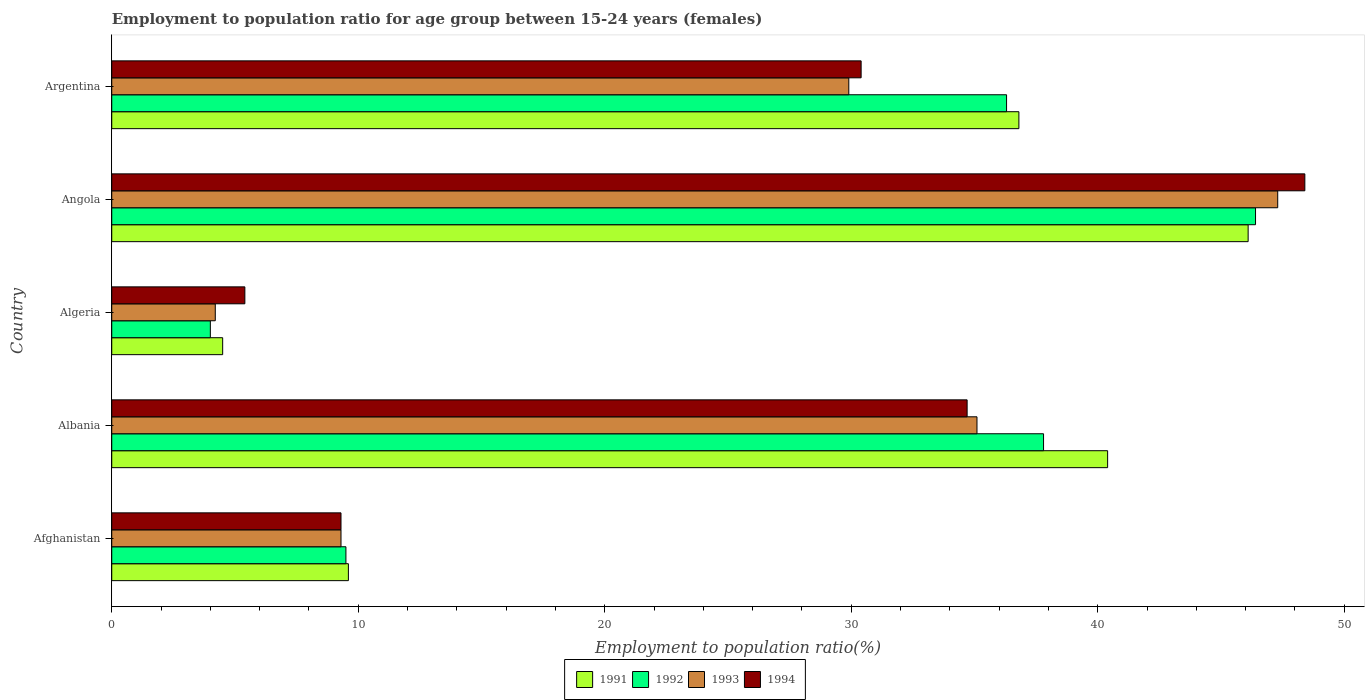How many different coloured bars are there?
Ensure brevity in your answer.  4. How many groups of bars are there?
Your answer should be compact. 5. What is the label of the 5th group of bars from the top?
Your response must be concise. Afghanistan. What is the employment to population ratio in 1993 in Angola?
Provide a short and direct response. 47.3. Across all countries, what is the maximum employment to population ratio in 1991?
Ensure brevity in your answer.  46.1. Across all countries, what is the minimum employment to population ratio in 1993?
Provide a succinct answer. 4.2. In which country was the employment to population ratio in 1994 maximum?
Your answer should be compact. Angola. In which country was the employment to population ratio in 1992 minimum?
Keep it short and to the point. Algeria. What is the total employment to population ratio in 1993 in the graph?
Keep it short and to the point. 125.8. What is the difference between the employment to population ratio in 1994 in Afghanistan and that in Argentina?
Keep it short and to the point. -21.1. What is the difference between the employment to population ratio in 1991 in Argentina and the employment to population ratio in 1992 in Algeria?
Ensure brevity in your answer.  32.8. What is the average employment to population ratio in 1991 per country?
Keep it short and to the point. 27.48. What is the difference between the employment to population ratio in 1992 and employment to population ratio in 1993 in Argentina?
Your response must be concise. 6.4. In how many countries, is the employment to population ratio in 1993 greater than 4 %?
Make the answer very short. 5. What is the ratio of the employment to population ratio in 1992 in Afghanistan to that in Albania?
Ensure brevity in your answer.  0.25. Is the employment to population ratio in 1992 in Afghanistan less than that in Argentina?
Provide a succinct answer. Yes. What is the difference between the highest and the second highest employment to population ratio in 1991?
Make the answer very short. 5.7. What is the difference between the highest and the lowest employment to population ratio in 1994?
Keep it short and to the point. 43. Is it the case that in every country, the sum of the employment to population ratio in 1993 and employment to population ratio in 1991 is greater than the sum of employment to population ratio in 1994 and employment to population ratio in 1992?
Offer a very short reply. No. Is it the case that in every country, the sum of the employment to population ratio in 1991 and employment to population ratio in 1993 is greater than the employment to population ratio in 1994?
Offer a terse response. Yes. Are the values on the major ticks of X-axis written in scientific E-notation?
Ensure brevity in your answer.  No. Does the graph contain any zero values?
Keep it short and to the point. No. How many legend labels are there?
Give a very brief answer. 4. What is the title of the graph?
Provide a succinct answer. Employment to population ratio for age group between 15-24 years (females). Does "1971" appear as one of the legend labels in the graph?
Ensure brevity in your answer.  No. What is the label or title of the X-axis?
Your answer should be compact. Employment to population ratio(%). What is the label or title of the Y-axis?
Offer a very short reply. Country. What is the Employment to population ratio(%) of 1991 in Afghanistan?
Provide a succinct answer. 9.6. What is the Employment to population ratio(%) in 1992 in Afghanistan?
Give a very brief answer. 9.5. What is the Employment to population ratio(%) of 1993 in Afghanistan?
Provide a succinct answer. 9.3. What is the Employment to population ratio(%) of 1994 in Afghanistan?
Your answer should be very brief. 9.3. What is the Employment to population ratio(%) in 1991 in Albania?
Offer a terse response. 40.4. What is the Employment to population ratio(%) of 1992 in Albania?
Your answer should be very brief. 37.8. What is the Employment to population ratio(%) in 1993 in Albania?
Ensure brevity in your answer.  35.1. What is the Employment to population ratio(%) of 1994 in Albania?
Offer a very short reply. 34.7. What is the Employment to population ratio(%) of 1992 in Algeria?
Offer a very short reply. 4. What is the Employment to population ratio(%) in 1993 in Algeria?
Give a very brief answer. 4.2. What is the Employment to population ratio(%) in 1994 in Algeria?
Your answer should be compact. 5.4. What is the Employment to population ratio(%) in 1991 in Angola?
Offer a terse response. 46.1. What is the Employment to population ratio(%) of 1992 in Angola?
Offer a terse response. 46.4. What is the Employment to population ratio(%) in 1993 in Angola?
Give a very brief answer. 47.3. What is the Employment to population ratio(%) of 1994 in Angola?
Provide a short and direct response. 48.4. What is the Employment to population ratio(%) of 1991 in Argentina?
Provide a succinct answer. 36.8. What is the Employment to population ratio(%) in 1992 in Argentina?
Make the answer very short. 36.3. What is the Employment to population ratio(%) in 1993 in Argentina?
Your answer should be compact. 29.9. What is the Employment to population ratio(%) of 1994 in Argentina?
Provide a succinct answer. 30.4. Across all countries, what is the maximum Employment to population ratio(%) in 1991?
Your response must be concise. 46.1. Across all countries, what is the maximum Employment to population ratio(%) of 1992?
Give a very brief answer. 46.4. Across all countries, what is the maximum Employment to population ratio(%) of 1993?
Ensure brevity in your answer.  47.3. Across all countries, what is the maximum Employment to population ratio(%) of 1994?
Offer a terse response. 48.4. Across all countries, what is the minimum Employment to population ratio(%) in 1991?
Your answer should be very brief. 4.5. Across all countries, what is the minimum Employment to population ratio(%) in 1993?
Ensure brevity in your answer.  4.2. Across all countries, what is the minimum Employment to population ratio(%) in 1994?
Your answer should be compact. 5.4. What is the total Employment to population ratio(%) of 1991 in the graph?
Make the answer very short. 137.4. What is the total Employment to population ratio(%) of 1992 in the graph?
Give a very brief answer. 134. What is the total Employment to population ratio(%) of 1993 in the graph?
Your response must be concise. 125.8. What is the total Employment to population ratio(%) in 1994 in the graph?
Your answer should be very brief. 128.2. What is the difference between the Employment to population ratio(%) of 1991 in Afghanistan and that in Albania?
Your response must be concise. -30.8. What is the difference between the Employment to population ratio(%) of 1992 in Afghanistan and that in Albania?
Provide a short and direct response. -28.3. What is the difference between the Employment to population ratio(%) in 1993 in Afghanistan and that in Albania?
Provide a short and direct response. -25.8. What is the difference between the Employment to population ratio(%) in 1994 in Afghanistan and that in Albania?
Your answer should be compact. -25.4. What is the difference between the Employment to population ratio(%) in 1991 in Afghanistan and that in Algeria?
Ensure brevity in your answer.  5.1. What is the difference between the Employment to population ratio(%) of 1993 in Afghanistan and that in Algeria?
Keep it short and to the point. 5.1. What is the difference between the Employment to population ratio(%) of 1994 in Afghanistan and that in Algeria?
Keep it short and to the point. 3.9. What is the difference between the Employment to population ratio(%) of 1991 in Afghanistan and that in Angola?
Keep it short and to the point. -36.5. What is the difference between the Employment to population ratio(%) of 1992 in Afghanistan and that in Angola?
Provide a short and direct response. -36.9. What is the difference between the Employment to population ratio(%) of 1993 in Afghanistan and that in Angola?
Provide a short and direct response. -38. What is the difference between the Employment to population ratio(%) in 1994 in Afghanistan and that in Angola?
Make the answer very short. -39.1. What is the difference between the Employment to population ratio(%) in 1991 in Afghanistan and that in Argentina?
Make the answer very short. -27.2. What is the difference between the Employment to population ratio(%) of 1992 in Afghanistan and that in Argentina?
Your answer should be very brief. -26.8. What is the difference between the Employment to population ratio(%) of 1993 in Afghanistan and that in Argentina?
Give a very brief answer. -20.6. What is the difference between the Employment to population ratio(%) in 1994 in Afghanistan and that in Argentina?
Offer a very short reply. -21.1. What is the difference between the Employment to population ratio(%) of 1991 in Albania and that in Algeria?
Your response must be concise. 35.9. What is the difference between the Employment to population ratio(%) of 1992 in Albania and that in Algeria?
Give a very brief answer. 33.8. What is the difference between the Employment to population ratio(%) of 1993 in Albania and that in Algeria?
Your answer should be very brief. 30.9. What is the difference between the Employment to population ratio(%) in 1994 in Albania and that in Algeria?
Ensure brevity in your answer.  29.3. What is the difference between the Employment to population ratio(%) in 1993 in Albania and that in Angola?
Provide a short and direct response. -12.2. What is the difference between the Employment to population ratio(%) of 1994 in Albania and that in Angola?
Offer a terse response. -13.7. What is the difference between the Employment to population ratio(%) of 1991 in Albania and that in Argentina?
Provide a succinct answer. 3.6. What is the difference between the Employment to population ratio(%) of 1992 in Albania and that in Argentina?
Offer a very short reply. 1.5. What is the difference between the Employment to population ratio(%) in 1991 in Algeria and that in Angola?
Make the answer very short. -41.6. What is the difference between the Employment to population ratio(%) in 1992 in Algeria and that in Angola?
Your response must be concise. -42.4. What is the difference between the Employment to population ratio(%) of 1993 in Algeria and that in Angola?
Your answer should be compact. -43.1. What is the difference between the Employment to population ratio(%) in 1994 in Algeria and that in Angola?
Your answer should be very brief. -43. What is the difference between the Employment to population ratio(%) in 1991 in Algeria and that in Argentina?
Offer a terse response. -32.3. What is the difference between the Employment to population ratio(%) of 1992 in Algeria and that in Argentina?
Your response must be concise. -32.3. What is the difference between the Employment to population ratio(%) in 1993 in Algeria and that in Argentina?
Ensure brevity in your answer.  -25.7. What is the difference between the Employment to population ratio(%) in 1994 in Algeria and that in Argentina?
Keep it short and to the point. -25. What is the difference between the Employment to population ratio(%) of 1992 in Angola and that in Argentina?
Offer a terse response. 10.1. What is the difference between the Employment to population ratio(%) of 1994 in Angola and that in Argentina?
Your answer should be compact. 18. What is the difference between the Employment to population ratio(%) in 1991 in Afghanistan and the Employment to population ratio(%) in 1992 in Albania?
Offer a very short reply. -28.2. What is the difference between the Employment to population ratio(%) of 1991 in Afghanistan and the Employment to population ratio(%) of 1993 in Albania?
Ensure brevity in your answer.  -25.5. What is the difference between the Employment to population ratio(%) in 1991 in Afghanistan and the Employment to population ratio(%) in 1994 in Albania?
Make the answer very short. -25.1. What is the difference between the Employment to population ratio(%) in 1992 in Afghanistan and the Employment to population ratio(%) in 1993 in Albania?
Keep it short and to the point. -25.6. What is the difference between the Employment to population ratio(%) of 1992 in Afghanistan and the Employment to population ratio(%) of 1994 in Albania?
Your response must be concise. -25.2. What is the difference between the Employment to population ratio(%) of 1993 in Afghanistan and the Employment to population ratio(%) of 1994 in Albania?
Keep it short and to the point. -25.4. What is the difference between the Employment to population ratio(%) in 1991 in Afghanistan and the Employment to population ratio(%) in 1992 in Algeria?
Your answer should be very brief. 5.6. What is the difference between the Employment to population ratio(%) of 1991 in Afghanistan and the Employment to population ratio(%) of 1993 in Algeria?
Keep it short and to the point. 5.4. What is the difference between the Employment to population ratio(%) in 1992 in Afghanistan and the Employment to population ratio(%) in 1993 in Algeria?
Keep it short and to the point. 5.3. What is the difference between the Employment to population ratio(%) in 1992 in Afghanistan and the Employment to population ratio(%) in 1994 in Algeria?
Provide a short and direct response. 4.1. What is the difference between the Employment to population ratio(%) of 1993 in Afghanistan and the Employment to population ratio(%) of 1994 in Algeria?
Keep it short and to the point. 3.9. What is the difference between the Employment to population ratio(%) of 1991 in Afghanistan and the Employment to population ratio(%) of 1992 in Angola?
Offer a very short reply. -36.8. What is the difference between the Employment to population ratio(%) in 1991 in Afghanistan and the Employment to population ratio(%) in 1993 in Angola?
Provide a short and direct response. -37.7. What is the difference between the Employment to population ratio(%) in 1991 in Afghanistan and the Employment to population ratio(%) in 1994 in Angola?
Offer a terse response. -38.8. What is the difference between the Employment to population ratio(%) of 1992 in Afghanistan and the Employment to population ratio(%) of 1993 in Angola?
Keep it short and to the point. -37.8. What is the difference between the Employment to population ratio(%) in 1992 in Afghanistan and the Employment to population ratio(%) in 1994 in Angola?
Ensure brevity in your answer.  -38.9. What is the difference between the Employment to population ratio(%) in 1993 in Afghanistan and the Employment to population ratio(%) in 1994 in Angola?
Provide a succinct answer. -39.1. What is the difference between the Employment to population ratio(%) of 1991 in Afghanistan and the Employment to population ratio(%) of 1992 in Argentina?
Keep it short and to the point. -26.7. What is the difference between the Employment to population ratio(%) of 1991 in Afghanistan and the Employment to population ratio(%) of 1993 in Argentina?
Ensure brevity in your answer.  -20.3. What is the difference between the Employment to population ratio(%) of 1991 in Afghanistan and the Employment to population ratio(%) of 1994 in Argentina?
Provide a succinct answer. -20.8. What is the difference between the Employment to population ratio(%) in 1992 in Afghanistan and the Employment to population ratio(%) in 1993 in Argentina?
Your answer should be very brief. -20.4. What is the difference between the Employment to population ratio(%) in 1992 in Afghanistan and the Employment to population ratio(%) in 1994 in Argentina?
Make the answer very short. -20.9. What is the difference between the Employment to population ratio(%) in 1993 in Afghanistan and the Employment to population ratio(%) in 1994 in Argentina?
Provide a succinct answer. -21.1. What is the difference between the Employment to population ratio(%) of 1991 in Albania and the Employment to population ratio(%) of 1992 in Algeria?
Keep it short and to the point. 36.4. What is the difference between the Employment to population ratio(%) of 1991 in Albania and the Employment to population ratio(%) of 1993 in Algeria?
Ensure brevity in your answer.  36.2. What is the difference between the Employment to population ratio(%) in 1991 in Albania and the Employment to population ratio(%) in 1994 in Algeria?
Provide a succinct answer. 35. What is the difference between the Employment to population ratio(%) in 1992 in Albania and the Employment to population ratio(%) in 1993 in Algeria?
Offer a terse response. 33.6. What is the difference between the Employment to population ratio(%) of 1992 in Albania and the Employment to population ratio(%) of 1994 in Algeria?
Your answer should be compact. 32.4. What is the difference between the Employment to population ratio(%) in 1993 in Albania and the Employment to population ratio(%) in 1994 in Algeria?
Give a very brief answer. 29.7. What is the difference between the Employment to population ratio(%) in 1991 in Albania and the Employment to population ratio(%) in 1992 in Angola?
Your answer should be compact. -6. What is the difference between the Employment to population ratio(%) of 1991 in Albania and the Employment to population ratio(%) of 1993 in Angola?
Provide a succinct answer. -6.9. What is the difference between the Employment to population ratio(%) in 1992 in Albania and the Employment to population ratio(%) in 1994 in Angola?
Provide a succinct answer. -10.6. What is the difference between the Employment to population ratio(%) in 1992 in Albania and the Employment to population ratio(%) in 1993 in Argentina?
Provide a short and direct response. 7.9. What is the difference between the Employment to population ratio(%) in 1992 in Albania and the Employment to population ratio(%) in 1994 in Argentina?
Offer a terse response. 7.4. What is the difference between the Employment to population ratio(%) in 1991 in Algeria and the Employment to population ratio(%) in 1992 in Angola?
Your answer should be very brief. -41.9. What is the difference between the Employment to population ratio(%) in 1991 in Algeria and the Employment to population ratio(%) in 1993 in Angola?
Keep it short and to the point. -42.8. What is the difference between the Employment to population ratio(%) of 1991 in Algeria and the Employment to population ratio(%) of 1994 in Angola?
Your response must be concise. -43.9. What is the difference between the Employment to population ratio(%) of 1992 in Algeria and the Employment to population ratio(%) of 1993 in Angola?
Make the answer very short. -43.3. What is the difference between the Employment to population ratio(%) of 1992 in Algeria and the Employment to population ratio(%) of 1994 in Angola?
Offer a terse response. -44.4. What is the difference between the Employment to population ratio(%) of 1993 in Algeria and the Employment to population ratio(%) of 1994 in Angola?
Ensure brevity in your answer.  -44.2. What is the difference between the Employment to population ratio(%) of 1991 in Algeria and the Employment to population ratio(%) of 1992 in Argentina?
Give a very brief answer. -31.8. What is the difference between the Employment to population ratio(%) in 1991 in Algeria and the Employment to population ratio(%) in 1993 in Argentina?
Provide a short and direct response. -25.4. What is the difference between the Employment to population ratio(%) in 1991 in Algeria and the Employment to population ratio(%) in 1994 in Argentina?
Your answer should be very brief. -25.9. What is the difference between the Employment to population ratio(%) in 1992 in Algeria and the Employment to population ratio(%) in 1993 in Argentina?
Keep it short and to the point. -25.9. What is the difference between the Employment to population ratio(%) in 1992 in Algeria and the Employment to population ratio(%) in 1994 in Argentina?
Your answer should be very brief. -26.4. What is the difference between the Employment to population ratio(%) in 1993 in Algeria and the Employment to population ratio(%) in 1994 in Argentina?
Provide a succinct answer. -26.2. What is the difference between the Employment to population ratio(%) in 1991 in Angola and the Employment to population ratio(%) in 1992 in Argentina?
Make the answer very short. 9.8. What is the difference between the Employment to population ratio(%) in 1991 in Angola and the Employment to population ratio(%) in 1993 in Argentina?
Offer a terse response. 16.2. What is the average Employment to population ratio(%) in 1991 per country?
Your response must be concise. 27.48. What is the average Employment to population ratio(%) in 1992 per country?
Keep it short and to the point. 26.8. What is the average Employment to population ratio(%) of 1993 per country?
Offer a terse response. 25.16. What is the average Employment to population ratio(%) in 1994 per country?
Make the answer very short. 25.64. What is the difference between the Employment to population ratio(%) of 1991 and Employment to population ratio(%) of 1993 in Afghanistan?
Give a very brief answer. 0.3. What is the difference between the Employment to population ratio(%) in 1991 and Employment to population ratio(%) in 1994 in Afghanistan?
Give a very brief answer. 0.3. What is the difference between the Employment to population ratio(%) of 1993 and Employment to population ratio(%) of 1994 in Afghanistan?
Keep it short and to the point. 0. What is the difference between the Employment to population ratio(%) of 1991 and Employment to population ratio(%) of 1994 in Albania?
Offer a terse response. 5.7. What is the difference between the Employment to population ratio(%) in 1992 and Employment to population ratio(%) in 1993 in Albania?
Offer a terse response. 2.7. What is the difference between the Employment to population ratio(%) of 1992 and Employment to population ratio(%) of 1994 in Albania?
Give a very brief answer. 3.1. What is the difference between the Employment to population ratio(%) of 1993 and Employment to population ratio(%) of 1994 in Albania?
Your answer should be compact. 0.4. What is the difference between the Employment to population ratio(%) in 1991 and Employment to population ratio(%) in 1994 in Algeria?
Provide a succinct answer. -0.9. What is the difference between the Employment to population ratio(%) of 1993 and Employment to population ratio(%) of 1994 in Algeria?
Offer a terse response. -1.2. What is the difference between the Employment to population ratio(%) of 1991 and Employment to population ratio(%) of 1993 in Angola?
Offer a terse response. -1.2. What is the difference between the Employment to population ratio(%) in 1991 and Employment to population ratio(%) in 1994 in Angola?
Give a very brief answer. -2.3. What is the difference between the Employment to population ratio(%) in 1992 and Employment to population ratio(%) in 1994 in Angola?
Provide a succinct answer. -2. What is the difference between the Employment to population ratio(%) of 1993 and Employment to population ratio(%) of 1994 in Angola?
Offer a very short reply. -1.1. What is the difference between the Employment to population ratio(%) in 1992 and Employment to population ratio(%) in 1993 in Argentina?
Keep it short and to the point. 6.4. What is the ratio of the Employment to population ratio(%) of 1991 in Afghanistan to that in Albania?
Provide a short and direct response. 0.24. What is the ratio of the Employment to population ratio(%) in 1992 in Afghanistan to that in Albania?
Your answer should be compact. 0.25. What is the ratio of the Employment to population ratio(%) in 1993 in Afghanistan to that in Albania?
Your answer should be very brief. 0.27. What is the ratio of the Employment to population ratio(%) in 1994 in Afghanistan to that in Albania?
Provide a succinct answer. 0.27. What is the ratio of the Employment to population ratio(%) of 1991 in Afghanistan to that in Algeria?
Keep it short and to the point. 2.13. What is the ratio of the Employment to population ratio(%) in 1992 in Afghanistan to that in Algeria?
Offer a terse response. 2.38. What is the ratio of the Employment to population ratio(%) of 1993 in Afghanistan to that in Algeria?
Your answer should be compact. 2.21. What is the ratio of the Employment to population ratio(%) of 1994 in Afghanistan to that in Algeria?
Offer a very short reply. 1.72. What is the ratio of the Employment to population ratio(%) in 1991 in Afghanistan to that in Angola?
Your response must be concise. 0.21. What is the ratio of the Employment to population ratio(%) of 1992 in Afghanistan to that in Angola?
Offer a very short reply. 0.2. What is the ratio of the Employment to population ratio(%) of 1993 in Afghanistan to that in Angola?
Provide a short and direct response. 0.2. What is the ratio of the Employment to population ratio(%) of 1994 in Afghanistan to that in Angola?
Offer a terse response. 0.19. What is the ratio of the Employment to population ratio(%) in 1991 in Afghanistan to that in Argentina?
Your response must be concise. 0.26. What is the ratio of the Employment to population ratio(%) in 1992 in Afghanistan to that in Argentina?
Your answer should be compact. 0.26. What is the ratio of the Employment to population ratio(%) of 1993 in Afghanistan to that in Argentina?
Your answer should be very brief. 0.31. What is the ratio of the Employment to population ratio(%) in 1994 in Afghanistan to that in Argentina?
Provide a succinct answer. 0.31. What is the ratio of the Employment to population ratio(%) of 1991 in Albania to that in Algeria?
Provide a short and direct response. 8.98. What is the ratio of the Employment to population ratio(%) in 1992 in Albania to that in Algeria?
Offer a terse response. 9.45. What is the ratio of the Employment to population ratio(%) of 1993 in Albania to that in Algeria?
Give a very brief answer. 8.36. What is the ratio of the Employment to population ratio(%) of 1994 in Albania to that in Algeria?
Your answer should be very brief. 6.43. What is the ratio of the Employment to population ratio(%) in 1991 in Albania to that in Angola?
Your answer should be compact. 0.88. What is the ratio of the Employment to population ratio(%) in 1992 in Albania to that in Angola?
Make the answer very short. 0.81. What is the ratio of the Employment to population ratio(%) in 1993 in Albania to that in Angola?
Ensure brevity in your answer.  0.74. What is the ratio of the Employment to population ratio(%) of 1994 in Albania to that in Angola?
Offer a terse response. 0.72. What is the ratio of the Employment to population ratio(%) in 1991 in Albania to that in Argentina?
Give a very brief answer. 1.1. What is the ratio of the Employment to population ratio(%) of 1992 in Albania to that in Argentina?
Your answer should be compact. 1.04. What is the ratio of the Employment to population ratio(%) of 1993 in Albania to that in Argentina?
Give a very brief answer. 1.17. What is the ratio of the Employment to population ratio(%) in 1994 in Albania to that in Argentina?
Provide a short and direct response. 1.14. What is the ratio of the Employment to population ratio(%) of 1991 in Algeria to that in Angola?
Keep it short and to the point. 0.1. What is the ratio of the Employment to population ratio(%) in 1992 in Algeria to that in Angola?
Give a very brief answer. 0.09. What is the ratio of the Employment to population ratio(%) of 1993 in Algeria to that in Angola?
Ensure brevity in your answer.  0.09. What is the ratio of the Employment to population ratio(%) of 1994 in Algeria to that in Angola?
Make the answer very short. 0.11. What is the ratio of the Employment to population ratio(%) in 1991 in Algeria to that in Argentina?
Give a very brief answer. 0.12. What is the ratio of the Employment to population ratio(%) in 1992 in Algeria to that in Argentina?
Offer a terse response. 0.11. What is the ratio of the Employment to population ratio(%) of 1993 in Algeria to that in Argentina?
Ensure brevity in your answer.  0.14. What is the ratio of the Employment to population ratio(%) of 1994 in Algeria to that in Argentina?
Give a very brief answer. 0.18. What is the ratio of the Employment to population ratio(%) in 1991 in Angola to that in Argentina?
Give a very brief answer. 1.25. What is the ratio of the Employment to population ratio(%) of 1992 in Angola to that in Argentina?
Offer a terse response. 1.28. What is the ratio of the Employment to population ratio(%) of 1993 in Angola to that in Argentina?
Offer a terse response. 1.58. What is the ratio of the Employment to population ratio(%) in 1994 in Angola to that in Argentina?
Ensure brevity in your answer.  1.59. What is the difference between the highest and the second highest Employment to population ratio(%) in 1992?
Your response must be concise. 8.6. What is the difference between the highest and the second highest Employment to population ratio(%) in 1994?
Keep it short and to the point. 13.7. What is the difference between the highest and the lowest Employment to population ratio(%) of 1991?
Provide a short and direct response. 41.6. What is the difference between the highest and the lowest Employment to population ratio(%) of 1992?
Your answer should be compact. 42.4. What is the difference between the highest and the lowest Employment to population ratio(%) in 1993?
Provide a succinct answer. 43.1. What is the difference between the highest and the lowest Employment to population ratio(%) of 1994?
Make the answer very short. 43. 